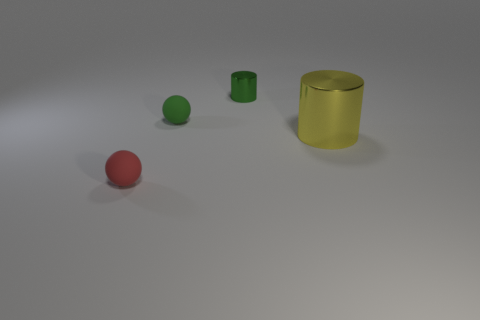What shape is the small rubber object that is the same color as the tiny cylinder?
Keep it short and to the point. Sphere. What is the size of the cylinder on the right side of the metal cylinder to the left of the metallic cylinder that is in front of the tiny shiny thing?
Keep it short and to the point. Large. How many other objects are there of the same material as the big yellow cylinder?
Make the answer very short. 1. There is a ball that is behind the big cylinder; how big is it?
Offer a very short reply. Small. What number of small things are both in front of the yellow cylinder and behind the red matte ball?
Give a very brief answer. 0. What is the material of the sphere behind the rubber sphere that is left of the green matte ball?
Keep it short and to the point. Rubber. What is the material of the tiny object that is the same shape as the big yellow metallic object?
Make the answer very short. Metal. Are there any small green metallic things?
Provide a succinct answer. Yes. There is a tiny green thing that is the same material as the small red ball; what shape is it?
Ensure brevity in your answer.  Sphere. There is a small ball that is in front of the tiny green rubber thing; what is its material?
Ensure brevity in your answer.  Rubber. 